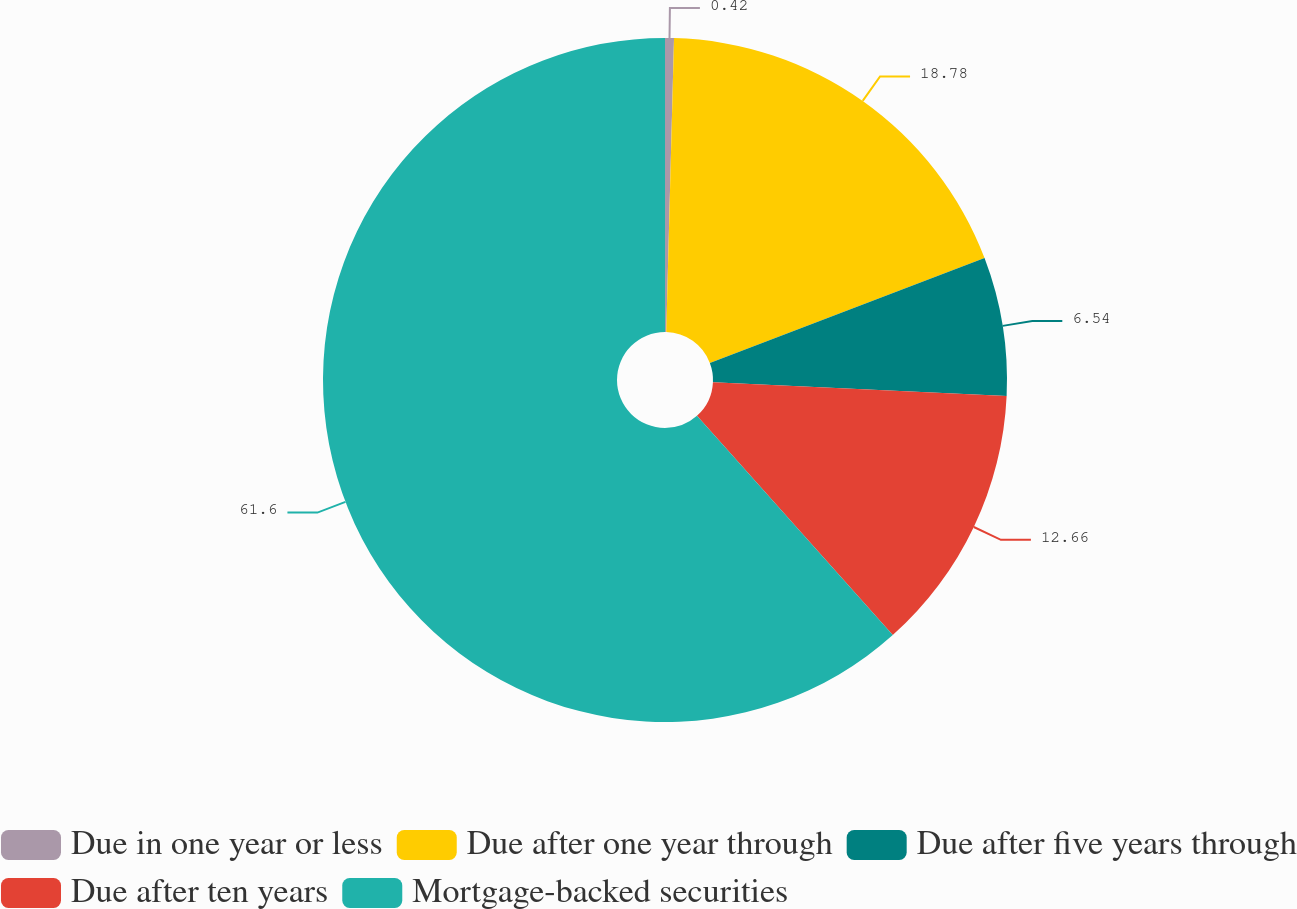<chart> <loc_0><loc_0><loc_500><loc_500><pie_chart><fcel>Due in one year or less<fcel>Due after one year through<fcel>Due after five years through<fcel>Due after ten years<fcel>Mortgage-backed securities<nl><fcel>0.42%<fcel>18.78%<fcel>6.54%<fcel>12.66%<fcel>61.6%<nl></chart> 